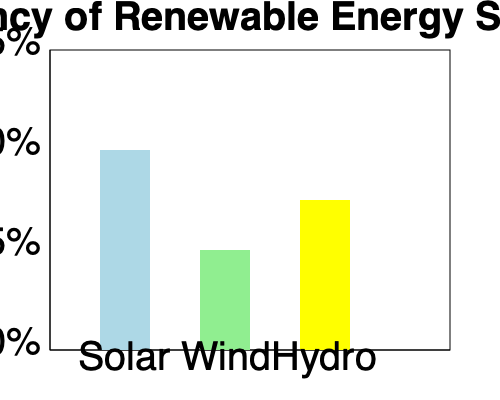Based on the bar graph showing the efficiency of different renewable energy sources, which source would be most suitable for powering gaming consoles in a region with limited water resources but abundant sunlight? Explain your reasoning and calculate the difference in efficiency between your chosen source and the next best alternative. To answer this question, we need to follow these steps:

1. Analyze the graph:
   - Solar: approximately 50% efficient
   - Wind: approximately 25% efficient
   - Hydro: approximately 37.5% efficient

2. Consider the given conditions:
   - Limited water resources
   - Abundant sunlight

3. Choose the most suitable energy source:
   Given the abundant sunlight and limited water resources, solar energy would be the most suitable option for powering gaming consoles in this region.

4. Explain the reasoning:
   - Solar has the highest efficiency (50%)
   - It takes advantage of the abundant sunlight in the region
   - It doesn't require water resources, unlike hydro power

5. Calculate the difference in efficiency:
   The next best alternative is hydro power at 37.5% efficiency.
   
   Difference = Solar efficiency - Hydro efficiency
               = 50% - 37.5%
               = 12.5%

Therefore, solar energy is 12.5% more efficient than the next best alternative (hydro power) for this specific scenario.
Answer: Solar; 12.5% more efficient than hydro 